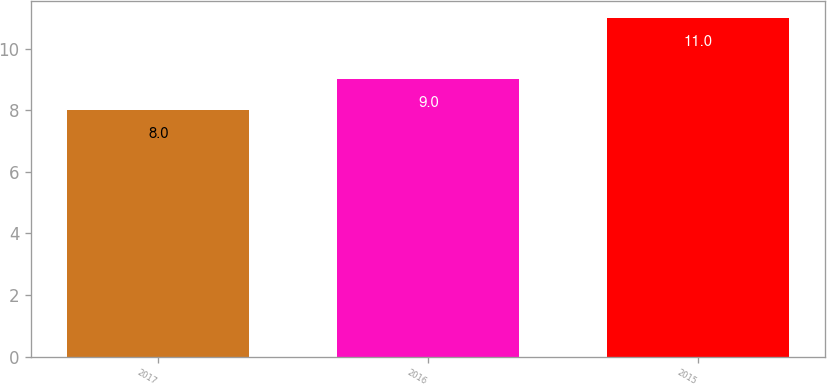<chart> <loc_0><loc_0><loc_500><loc_500><bar_chart><fcel>2017<fcel>2016<fcel>2015<nl><fcel>8<fcel>9<fcel>11<nl></chart> 